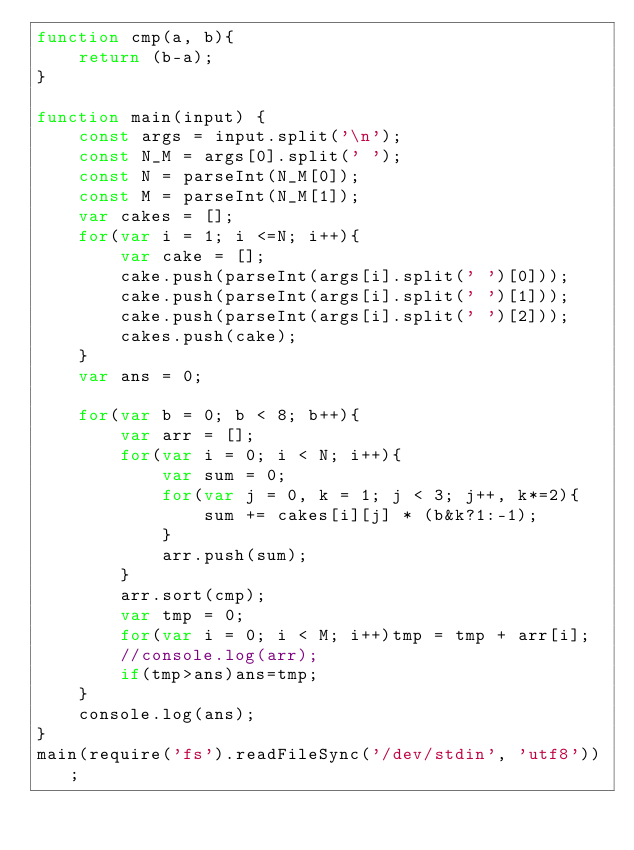<code> <loc_0><loc_0><loc_500><loc_500><_JavaScript_>function cmp(a, b){
    return (b-a);
}

function main(input) {
    const args = input.split('\n');
    const N_M = args[0].split(' ');
    const N = parseInt(N_M[0]);
    const M = parseInt(N_M[1]);
    var cakes = [];
    for(var i = 1; i <=N; i++){
        var cake = [];
        cake.push(parseInt(args[i].split(' ')[0]));
        cake.push(parseInt(args[i].split(' ')[1]));
        cake.push(parseInt(args[i].split(' ')[2]));
        cakes.push(cake);
    }
    var ans = 0;
    
    for(var b = 0; b < 8; b++){
        var arr = [];
        for(var i = 0; i < N; i++){
            var sum = 0;
            for(var j = 0, k = 1; j < 3; j++, k*=2){
                sum += cakes[i][j] * (b&k?1:-1);
            }
            arr.push(sum);
        }
        arr.sort(cmp);
        var tmp = 0;
        for(var i = 0; i < M; i++)tmp = tmp + arr[i];
        //console.log(arr);
        if(tmp>ans)ans=tmp;
    }
    console.log(ans);
}
main(require('fs').readFileSync('/dev/stdin', 'utf8'));</code> 